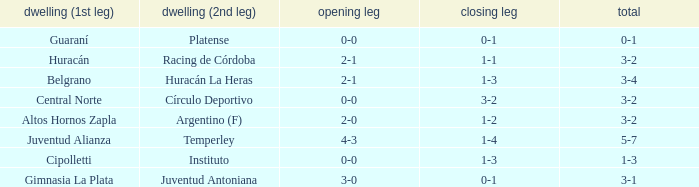Who played at home for the second leg with a score of 0-1 and tied 0-0 in the first leg? Platense. 